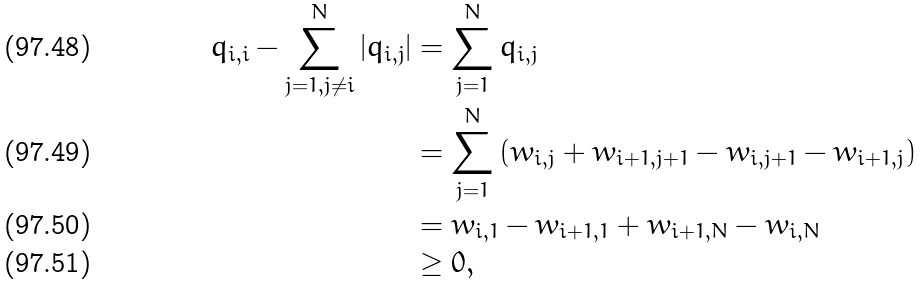Convert formula to latex. <formula><loc_0><loc_0><loc_500><loc_500>q _ { i , i } - \sum _ { j = 1 , j \neq i } ^ { N } | q _ { i , j } | & = \sum _ { j = 1 } ^ { N } q _ { i , j } \\ & = \sum _ { j = 1 } ^ { N } \left ( w _ { i , j } + w _ { i + 1 , j + 1 } - w _ { i , j + 1 } - w _ { i + 1 , j } \right ) \\ & = w _ { i , 1 } - w _ { i + 1 , 1 } + w _ { i + 1 , N } - w _ { i , N } \\ & \geq 0 ,</formula> 